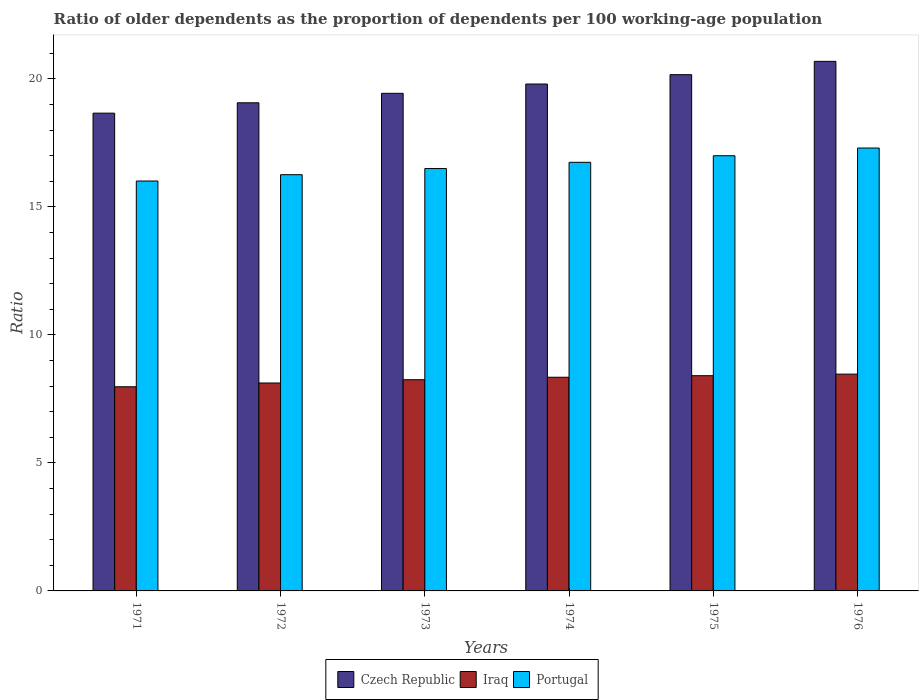How many different coloured bars are there?
Give a very brief answer. 3. Are the number of bars per tick equal to the number of legend labels?
Offer a very short reply. Yes. How many bars are there on the 4th tick from the left?
Ensure brevity in your answer.  3. How many bars are there on the 1st tick from the right?
Keep it short and to the point. 3. What is the age dependency ratio(old) in Czech Republic in 1971?
Make the answer very short. 18.66. Across all years, what is the maximum age dependency ratio(old) in Portugal?
Your response must be concise. 17.3. Across all years, what is the minimum age dependency ratio(old) in Portugal?
Offer a very short reply. 16.01. In which year was the age dependency ratio(old) in Iraq maximum?
Provide a short and direct response. 1976. In which year was the age dependency ratio(old) in Czech Republic minimum?
Your answer should be very brief. 1971. What is the total age dependency ratio(old) in Czech Republic in the graph?
Offer a terse response. 117.8. What is the difference between the age dependency ratio(old) in Portugal in 1975 and that in 1976?
Offer a very short reply. -0.3. What is the difference between the age dependency ratio(old) in Czech Republic in 1972 and the age dependency ratio(old) in Portugal in 1971?
Ensure brevity in your answer.  3.05. What is the average age dependency ratio(old) in Portugal per year?
Provide a short and direct response. 16.63. In the year 1972, what is the difference between the age dependency ratio(old) in Portugal and age dependency ratio(old) in Iraq?
Provide a succinct answer. 8.14. In how many years, is the age dependency ratio(old) in Iraq greater than 7?
Give a very brief answer. 6. What is the ratio of the age dependency ratio(old) in Iraq in 1972 to that in 1974?
Your answer should be very brief. 0.97. What is the difference between the highest and the second highest age dependency ratio(old) in Portugal?
Keep it short and to the point. 0.3. What is the difference between the highest and the lowest age dependency ratio(old) in Czech Republic?
Offer a terse response. 2.02. In how many years, is the age dependency ratio(old) in Portugal greater than the average age dependency ratio(old) in Portugal taken over all years?
Give a very brief answer. 3. What does the 1st bar from the left in 1976 represents?
Your answer should be very brief. Czech Republic. Are all the bars in the graph horizontal?
Provide a short and direct response. No. How many years are there in the graph?
Offer a very short reply. 6. What is the difference between two consecutive major ticks on the Y-axis?
Your response must be concise. 5. Are the values on the major ticks of Y-axis written in scientific E-notation?
Your answer should be very brief. No. Does the graph contain any zero values?
Make the answer very short. No. Does the graph contain grids?
Offer a terse response. No. Where does the legend appear in the graph?
Your answer should be compact. Bottom center. How many legend labels are there?
Offer a terse response. 3. What is the title of the graph?
Your response must be concise. Ratio of older dependents as the proportion of dependents per 100 working-age population. Does "Bangladesh" appear as one of the legend labels in the graph?
Provide a short and direct response. No. What is the label or title of the Y-axis?
Give a very brief answer. Ratio. What is the Ratio of Czech Republic in 1971?
Keep it short and to the point. 18.66. What is the Ratio of Iraq in 1971?
Provide a short and direct response. 7.97. What is the Ratio in Portugal in 1971?
Keep it short and to the point. 16.01. What is the Ratio in Czech Republic in 1972?
Provide a succinct answer. 19.06. What is the Ratio in Iraq in 1972?
Provide a succinct answer. 8.12. What is the Ratio of Portugal in 1972?
Provide a short and direct response. 16.26. What is the Ratio of Czech Republic in 1973?
Provide a short and direct response. 19.43. What is the Ratio of Iraq in 1973?
Your answer should be compact. 8.25. What is the Ratio in Portugal in 1973?
Provide a succinct answer. 16.5. What is the Ratio of Czech Republic in 1974?
Provide a short and direct response. 19.8. What is the Ratio of Iraq in 1974?
Offer a very short reply. 8.35. What is the Ratio in Portugal in 1974?
Offer a very short reply. 16.74. What is the Ratio in Czech Republic in 1975?
Your answer should be compact. 20.16. What is the Ratio of Iraq in 1975?
Your answer should be very brief. 8.41. What is the Ratio of Portugal in 1975?
Your answer should be very brief. 17. What is the Ratio in Czech Republic in 1976?
Your answer should be compact. 20.68. What is the Ratio of Iraq in 1976?
Offer a terse response. 8.47. What is the Ratio of Portugal in 1976?
Provide a succinct answer. 17.3. Across all years, what is the maximum Ratio in Czech Republic?
Offer a very short reply. 20.68. Across all years, what is the maximum Ratio of Iraq?
Keep it short and to the point. 8.47. Across all years, what is the maximum Ratio of Portugal?
Offer a terse response. 17.3. Across all years, what is the minimum Ratio of Czech Republic?
Offer a very short reply. 18.66. Across all years, what is the minimum Ratio in Iraq?
Offer a terse response. 7.97. Across all years, what is the minimum Ratio in Portugal?
Make the answer very short. 16.01. What is the total Ratio of Czech Republic in the graph?
Offer a very short reply. 117.8. What is the total Ratio of Iraq in the graph?
Your answer should be very brief. 49.56. What is the total Ratio of Portugal in the graph?
Ensure brevity in your answer.  99.8. What is the difference between the Ratio of Czech Republic in 1971 and that in 1972?
Keep it short and to the point. -0.4. What is the difference between the Ratio in Iraq in 1971 and that in 1972?
Provide a short and direct response. -0.15. What is the difference between the Ratio in Portugal in 1971 and that in 1972?
Offer a very short reply. -0.25. What is the difference between the Ratio in Czech Republic in 1971 and that in 1973?
Your answer should be very brief. -0.77. What is the difference between the Ratio of Iraq in 1971 and that in 1973?
Keep it short and to the point. -0.27. What is the difference between the Ratio of Portugal in 1971 and that in 1973?
Your answer should be compact. -0.49. What is the difference between the Ratio of Czech Republic in 1971 and that in 1974?
Ensure brevity in your answer.  -1.14. What is the difference between the Ratio of Iraq in 1971 and that in 1974?
Your answer should be compact. -0.37. What is the difference between the Ratio in Portugal in 1971 and that in 1974?
Ensure brevity in your answer.  -0.73. What is the difference between the Ratio in Czech Republic in 1971 and that in 1975?
Make the answer very short. -1.5. What is the difference between the Ratio in Iraq in 1971 and that in 1975?
Make the answer very short. -0.43. What is the difference between the Ratio of Portugal in 1971 and that in 1975?
Offer a very short reply. -0.99. What is the difference between the Ratio of Czech Republic in 1971 and that in 1976?
Provide a short and direct response. -2.02. What is the difference between the Ratio in Iraq in 1971 and that in 1976?
Offer a very short reply. -0.49. What is the difference between the Ratio in Portugal in 1971 and that in 1976?
Ensure brevity in your answer.  -1.29. What is the difference between the Ratio in Czech Republic in 1972 and that in 1973?
Your answer should be compact. -0.37. What is the difference between the Ratio of Iraq in 1972 and that in 1973?
Your response must be concise. -0.13. What is the difference between the Ratio in Portugal in 1972 and that in 1973?
Ensure brevity in your answer.  -0.24. What is the difference between the Ratio in Czech Republic in 1972 and that in 1974?
Ensure brevity in your answer.  -0.73. What is the difference between the Ratio of Iraq in 1972 and that in 1974?
Your response must be concise. -0.22. What is the difference between the Ratio in Portugal in 1972 and that in 1974?
Ensure brevity in your answer.  -0.48. What is the difference between the Ratio of Czech Republic in 1972 and that in 1975?
Offer a very short reply. -1.1. What is the difference between the Ratio of Iraq in 1972 and that in 1975?
Make the answer very short. -0.29. What is the difference between the Ratio of Portugal in 1972 and that in 1975?
Your answer should be compact. -0.74. What is the difference between the Ratio in Czech Republic in 1972 and that in 1976?
Your answer should be very brief. -1.62. What is the difference between the Ratio in Iraq in 1972 and that in 1976?
Provide a succinct answer. -0.35. What is the difference between the Ratio in Portugal in 1972 and that in 1976?
Provide a short and direct response. -1.04. What is the difference between the Ratio in Czech Republic in 1973 and that in 1974?
Keep it short and to the point. -0.36. What is the difference between the Ratio of Iraq in 1973 and that in 1974?
Your response must be concise. -0.1. What is the difference between the Ratio of Portugal in 1973 and that in 1974?
Offer a very short reply. -0.24. What is the difference between the Ratio in Czech Republic in 1973 and that in 1975?
Keep it short and to the point. -0.73. What is the difference between the Ratio of Iraq in 1973 and that in 1975?
Your answer should be compact. -0.16. What is the difference between the Ratio of Portugal in 1973 and that in 1975?
Give a very brief answer. -0.5. What is the difference between the Ratio in Czech Republic in 1973 and that in 1976?
Provide a succinct answer. -1.25. What is the difference between the Ratio in Iraq in 1973 and that in 1976?
Your answer should be compact. -0.22. What is the difference between the Ratio in Portugal in 1973 and that in 1976?
Provide a short and direct response. -0.8. What is the difference between the Ratio in Czech Republic in 1974 and that in 1975?
Ensure brevity in your answer.  -0.37. What is the difference between the Ratio of Iraq in 1974 and that in 1975?
Make the answer very short. -0.06. What is the difference between the Ratio of Portugal in 1974 and that in 1975?
Your answer should be very brief. -0.26. What is the difference between the Ratio in Czech Republic in 1974 and that in 1976?
Give a very brief answer. -0.89. What is the difference between the Ratio of Iraq in 1974 and that in 1976?
Your answer should be compact. -0.12. What is the difference between the Ratio in Portugal in 1974 and that in 1976?
Offer a terse response. -0.56. What is the difference between the Ratio in Czech Republic in 1975 and that in 1976?
Keep it short and to the point. -0.52. What is the difference between the Ratio in Iraq in 1975 and that in 1976?
Provide a succinct answer. -0.06. What is the difference between the Ratio in Portugal in 1975 and that in 1976?
Keep it short and to the point. -0.3. What is the difference between the Ratio in Czech Republic in 1971 and the Ratio in Iraq in 1972?
Your response must be concise. 10.54. What is the difference between the Ratio in Czech Republic in 1971 and the Ratio in Portugal in 1972?
Provide a short and direct response. 2.4. What is the difference between the Ratio of Iraq in 1971 and the Ratio of Portugal in 1972?
Offer a very short reply. -8.28. What is the difference between the Ratio in Czech Republic in 1971 and the Ratio in Iraq in 1973?
Keep it short and to the point. 10.41. What is the difference between the Ratio of Czech Republic in 1971 and the Ratio of Portugal in 1973?
Offer a terse response. 2.16. What is the difference between the Ratio of Iraq in 1971 and the Ratio of Portugal in 1973?
Provide a succinct answer. -8.52. What is the difference between the Ratio in Czech Republic in 1971 and the Ratio in Iraq in 1974?
Offer a terse response. 10.31. What is the difference between the Ratio of Czech Republic in 1971 and the Ratio of Portugal in 1974?
Your answer should be very brief. 1.92. What is the difference between the Ratio of Iraq in 1971 and the Ratio of Portugal in 1974?
Provide a short and direct response. -8.77. What is the difference between the Ratio of Czech Republic in 1971 and the Ratio of Iraq in 1975?
Keep it short and to the point. 10.25. What is the difference between the Ratio in Czech Republic in 1971 and the Ratio in Portugal in 1975?
Your answer should be very brief. 1.66. What is the difference between the Ratio in Iraq in 1971 and the Ratio in Portugal in 1975?
Your response must be concise. -9.02. What is the difference between the Ratio in Czech Republic in 1971 and the Ratio in Iraq in 1976?
Your answer should be compact. 10.19. What is the difference between the Ratio in Czech Republic in 1971 and the Ratio in Portugal in 1976?
Ensure brevity in your answer.  1.36. What is the difference between the Ratio of Iraq in 1971 and the Ratio of Portugal in 1976?
Give a very brief answer. -9.32. What is the difference between the Ratio of Czech Republic in 1972 and the Ratio of Iraq in 1973?
Offer a very short reply. 10.82. What is the difference between the Ratio of Czech Republic in 1972 and the Ratio of Portugal in 1973?
Ensure brevity in your answer.  2.57. What is the difference between the Ratio of Iraq in 1972 and the Ratio of Portugal in 1973?
Provide a succinct answer. -8.38. What is the difference between the Ratio in Czech Republic in 1972 and the Ratio in Iraq in 1974?
Your answer should be very brief. 10.72. What is the difference between the Ratio in Czech Republic in 1972 and the Ratio in Portugal in 1974?
Your response must be concise. 2.32. What is the difference between the Ratio in Iraq in 1972 and the Ratio in Portugal in 1974?
Ensure brevity in your answer.  -8.62. What is the difference between the Ratio of Czech Republic in 1972 and the Ratio of Iraq in 1975?
Your answer should be compact. 10.66. What is the difference between the Ratio of Czech Republic in 1972 and the Ratio of Portugal in 1975?
Provide a succinct answer. 2.07. What is the difference between the Ratio in Iraq in 1972 and the Ratio in Portugal in 1975?
Your response must be concise. -8.88. What is the difference between the Ratio of Czech Republic in 1972 and the Ratio of Iraq in 1976?
Give a very brief answer. 10.6. What is the difference between the Ratio of Czech Republic in 1972 and the Ratio of Portugal in 1976?
Provide a succinct answer. 1.77. What is the difference between the Ratio of Iraq in 1972 and the Ratio of Portugal in 1976?
Offer a terse response. -9.18. What is the difference between the Ratio of Czech Republic in 1973 and the Ratio of Iraq in 1974?
Your answer should be compact. 11.09. What is the difference between the Ratio of Czech Republic in 1973 and the Ratio of Portugal in 1974?
Your response must be concise. 2.69. What is the difference between the Ratio of Iraq in 1973 and the Ratio of Portugal in 1974?
Offer a very short reply. -8.49. What is the difference between the Ratio of Czech Republic in 1973 and the Ratio of Iraq in 1975?
Offer a terse response. 11.03. What is the difference between the Ratio of Czech Republic in 1973 and the Ratio of Portugal in 1975?
Your answer should be very brief. 2.44. What is the difference between the Ratio of Iraq in 1973 and the Ratio of Portugal in 1975?
Offer a very short reply. -8.75. What is the difference between the Ratio in Czech Republic in 1973 and the Ratio in Iraq in 1976?
Provide a short and direct response. 10.97. What is the difference between the Ratio in Czech Republic in 1973 and the Ratio in Portugal in 1976?
Your answer should be compact. 2.14. What is the difference between the Ratio of Iraq in 1973 and the Ratio of Portugal in 1976?
Keep it short and to the point. -9.05. What is the difference between the Ratio of Czech Republic in 1974 and the Ratio of Iraq in 1975?
Provide a succinct answer. 11.39. What is the difference between the Ratio of Czech Republic in 1974 and the Ratio of Portugal in 1975?
Make the answer very short. 2.8. What is the difference between the Ratio of Iraq in 1974 and the Ratio of Portugal in 1975?
Your response must be concise. -8.65. What is the difference between the Ratio of Czech Republic in 1974 and the Ratio of Iraq in 1976?
Make the answer very short. 11.33. What is the difference between the Ratio in Czech Republic in 1974 and the Ratio in Portugal in 1976?
Your response must be concise. 2.5. What is the difference between the Ratio of Iraq in 1974 and the Ratio of Portugal in 1976?
Your response must be concise. -8.95. What is the difference between the Ratio in Czech Republic in 1975 and the Ratio in Iraq in 1976?
Give a very brief answer. 11.7. What is the difference between the Ratio of Czech Republic in 1975 and the Ratio of Portugal in 1976?
Provide a short and direct response. 2.87. What is the difference between the Ratio in Iraq in 1975 and the Ratio in Portugal in 1976?
Offer a very short reply. -8.89. What is the average Ratio in Czech Republic per year?
Keep it short and to the point. 19.63. What is the average Ratio in Iraq per year?
Offer a terse response. 8.26. What is the average Ratio of Portugal per year?
Give a very brief answer. 16.63. In the year 1971, what is the difference between the Ratio of Czech Republic and Ratio of Iraq?
Offer a terse response. 10.69. In the year 1971, what is the difference between the Ratio in Czech Republic and Ratio in Portugal?
Make the answer very short. 2.65. In the year 1971, what is the difference between the Ratio in Iraq and Ratio in Portugal?
Provide a succinct answer. -8.04. In the year 1972, what is the difference between the Ratio in Czech Republic and Ratio in Iraq?
Give a very brief answer. 10.94. In the year 1972, what is the difference between the Ratio of Czech Republic and Ratio of Portugal?
Your answer should be compact. 2.81. In the year 1972, what is the difference between the Ratio in Iraq and Ratio in Portugal?
Keep it short and to the point. -8.14. In the year 1973, what is the difference between the Ratio of Czech Republic and Ratio of Iraq?
Keep it short and to the point. 11.19. In the year 1973, what is the difference between the Ratio of Czech Republic and Ratio of Portugal?
Give a very brief answer. 2.94. In the year 1973, what is the difference between the Ratio in Iraq and Ratio in Portugal?
Keep it short and to the point. -8.25. In the year 1974, what is the difference between the Ratio in Czech Republic and Ratio in Iraq?
Give a very brief answer. 11.45. In the year 1974, what is the difference between the Ratio in Czech Republic and Ratio in Portugal?
Provide a short and direct response. 3.06. In the year 1974, what is the difference between the Ratio of Iraq and Ratio of Portugal?
Offer a terse response. -8.39. In the year 1975, what is the difference between the Ratio in Czech Republic and Ratio in Iraq?
Your response must be concise. 11.76. In the year 1975, what is the difference between the Ratio in Czech Republic and Ratio in Portugal?
Offer a very short reply. 3.17. In the year 1975, what is the difference between the Ratio of Iraq and Ratio of Portugal?
Offer a very short reply. -8.59. In the year 1976, what is the difference between the Ratio in Czech Republic and Ratio in Iraq?
Keep it short and to the point. 12.22. In the year 1976, what is the difference between the Ratio of Czech Republic and Ratio of Portugal?
Provide a short and direct response. 3.39. In the year 1976, what is the difference between the Ratio of Iraq and Ratio of Portugal?
Provide a short and direct response. -8.83. What is the ratio of the Ratio in Czech Republic in 1971 to that in 1972?
Your response must be concise. 0.98. What is the ratio of the Ratio of Iraq in 1971 to that in 1972?
Your response must be concise. 0.98. What is the ratio of the Ratio in Portugal in 1971 to that in 1972?
Provide a succinct answer. 0.98. What is the ratio of the Ratio of Czech Republic in 1971 to that in 1973?
Keep it short and to the point. 0.96. What is the ratio of the Ratio of Iraq in 1971 to that in 1973?
Keep it short and to the point. 0.97. What is the ratio of the Ratio in Portugal in 1971 to that in 1973?
Your answer should be compact. 0.97. What is the ratio of the Ratio in Czech Republic in 1971 to that in 1974?
Your response must be concise. 0.94. What is the ratio of the Ratio of Iraq in 1971 to that in 1974?
Your response must be concise. 0.96. What is the ratio of the Ratio in Portugal in 1971 to that in 1974?
Offer a very short reply. 0.96. What is the ratio of the Ratio in Czech Republic in 1971 to that in 1975?
Provide a succinct answer. 0.93. What is the ratio of the Ratio of Iraq in 1971 to that in 1975?
Keep it short and to the point. 0.95. What is the ratio of the Ratio of Portugal in 1971 to that in 1975?
Your answer should be compact. 0.94. What is the ratio of the Ratio of Czech Republic in 1971 to that in 1976?
Offer a terse response. 0.9. What is the ratio of the Ratio in Iraq in 1971 to that in 1976?
Provide a short and direct response. 0.94. What is the ratio of the Ratio in Portugal in 1971 to that in 1976?
Offer a very short reply. 0.93. What is the ratio of the Ratio in Czech Republic in 1972 to that in 1973?
Make the answer very short. 0.98. What is the ratio of the Ratio of Iraq in 1972 to that in 1973?
Your response must be concise. 0.98. What is the ratio of the Ratio in Portugal in 1972 to that in 1973?
Make the answer very short. 0.99. What is the ratio of the Ratio in Iraq in 1972 to that in 1974?
Give a very brief answer. 0.97. What is the ratio of the Ratio in Portugal in 1972 to that in 1974?
Ensure brevity in your answer.  0.97. What is the ratio of the Ratio in Czech Republic in 1972 to that in 1975?
Offer a very short reply. 0.95. What is the ratio of the Ratio in Portugal in 1972 to that in 1975?
Provide a succinct answer. 0.96. What is the ratio of the Ratio in Czech Republic in 1972 to that in 1976?
Keep it short and to the point. 0.92. What is the ratio of the Ratio of Iraq in 1972 to that in 1976?
Your response must be concise. 0.96. What is the ratio of the Ratio in Portugal in 1972 to that in 1976?
Your response must be concise. 0.94. What is the ratio of the Ratio of Czech Republic in 1973 to that in 1974?
Your answer should be compact. 0.98. What is the ratio of the Ratio of Iraq in 1973 to that in 1974?
Offer a terse response. 0.99. What is the ratio of the Ratio of Portugal in 1973 to that in 1974?
Keep it short and to the point. 0.99. What is the ratio of the Ratio in Czech Republic in 1973 to that in 1975?
Offer a terse response. 0.96. What is the ratio of the Ratio in Iraq in 1973 to that in 1975?
Your response must be concise. 0.98. What is the ratio of the Ratio in Portugal in 1973 to that in 1975?
Ensure brevity in your answer.  0.97. What is the ratio of the Ratio in Czech Republic in 1973 to that in 1976?
Your answer should be very brief. 0.94. What is the ratio of the Ratio in Iraq in 1973 to that in 1976?
Provide a short and direct response. 0.97. What is the ratio of the Ratio of Portugal in 1973 to that in 1976?
Offer a very short reply. 0.95. What is the ratio of the Ratio of Czech Republic in 1974 to that in 1975?
Offer a very short reply. 0.98. What is the ratio of the Ratio of Iraq in 1974 to that in 1975?
Offer a terse response. 0.99. What is the ratio of the Ratio of Portugal in 1974 to that in 1975?
Keep it short and to the point. 0.98. What is the ratio of the Ratio of Czech Republic in 1974 to that in 1976?
Keep it short and to the point. 0.96. What is the ratio of the Ratio of Iraq in 1974 to that in 1976?
Make the answer very short. 0.99. What is the ratio of the Ratio in Portugal in 1974 to that in 1976?
Offer a very short reply. 0.97. What is the ratio of the Ratio of Czech Republic in 1975 to that in 1976?
Offer a very short reply. 0.97. What is the ratio of the Ratio in Iraq in 1975 to that in 1976?
Keep it short and to the point. 0.99. What is the ratio of the Ratio of Portugal in 1975 to that in 1976?
Your answer should be compact. 0.98. What is the difference between the highest and the second highest Ratio in Czech Republic?
Your response must be concise. 0.52. What is the difference between the highest and the second highest Ratio of Iraq?
Ensure brevity in your answer.  0.06. What is the difference between the highest and the second highest Ratio of Portugal?
Ensure brevity in your answer.  0.3. What is the difference between the highest and the lowest Ratio of Czech Republic?
Give a very brief answer. 2.02. What is the difference between the highest and the lowest Ratio of Iraq?
Provide a short and direct response. 0.49. What is the difference between the highest and the lowest Ratio of Portugal?
Provide a succinct answer. 1.29. 